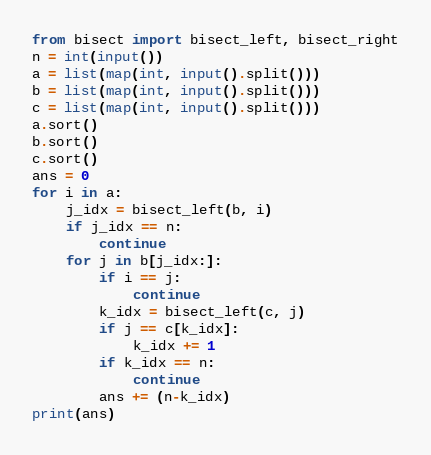<code> <loc_0><loc_0><loc_500><loc_500><_Python_>from bisect import bisect_left, bisect_right
n = int(input())
a = list(map(int, input().split()))
b = list(map(int, input().split()))
c = list(map(int, input().split()))
a.sort()
b.sort()
c.sort()
ans = 0
for i in a:
    j_idx = bisect_left(b, i)
    if j_idx == n:
        continue
    for j in b[j_idx:]:
        if i == j:
            continue
        k_idx = bisect_left(c, j)
        if j == c[k_idx]:
            k_idx += 1
        if k_idx == n:
            continue
        ans += (n-k_idx)
print(ans)

</code> 